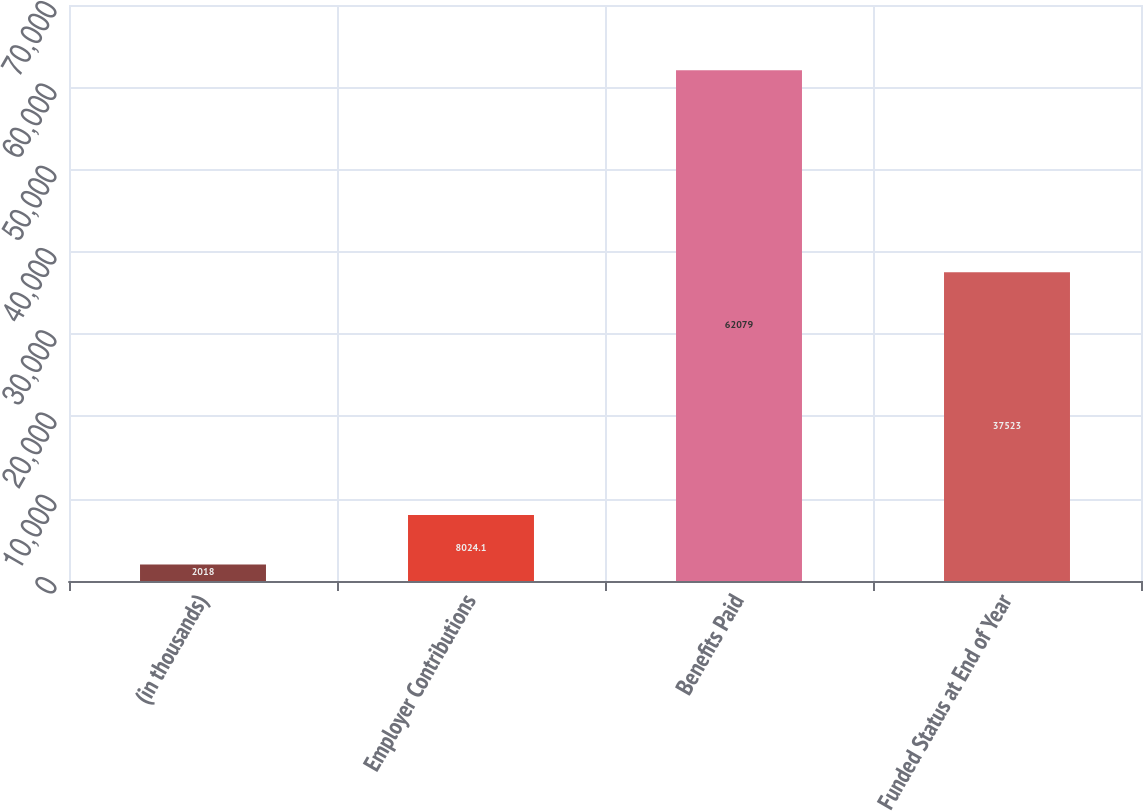<chart> <loc_0><loc_0><loc_500><loc_500><bar_chart><fcel>(in thousands)<fcel>Employer Contributions<fcel>Benefits Paid<fcel>Funded Status at End of Year<nl><fcel>2018<fcel>8024.1<fcel>62079<fcel>37523<nl></chart> 